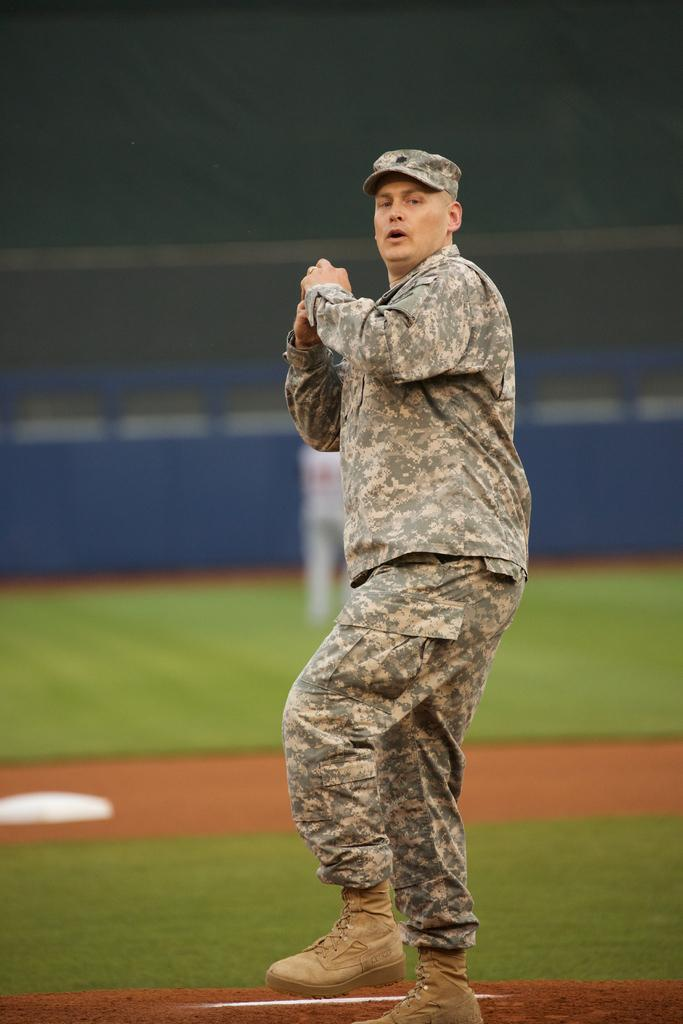Who is the main subject in the image? There is a man standing in the center of the image. What can be seen in the background of the image? There is a board and the ground visible in the background of the image. How many stems are visible in the image? There are no stems present in the image. What type of door can be seen in the image? There is no door present in the image. 